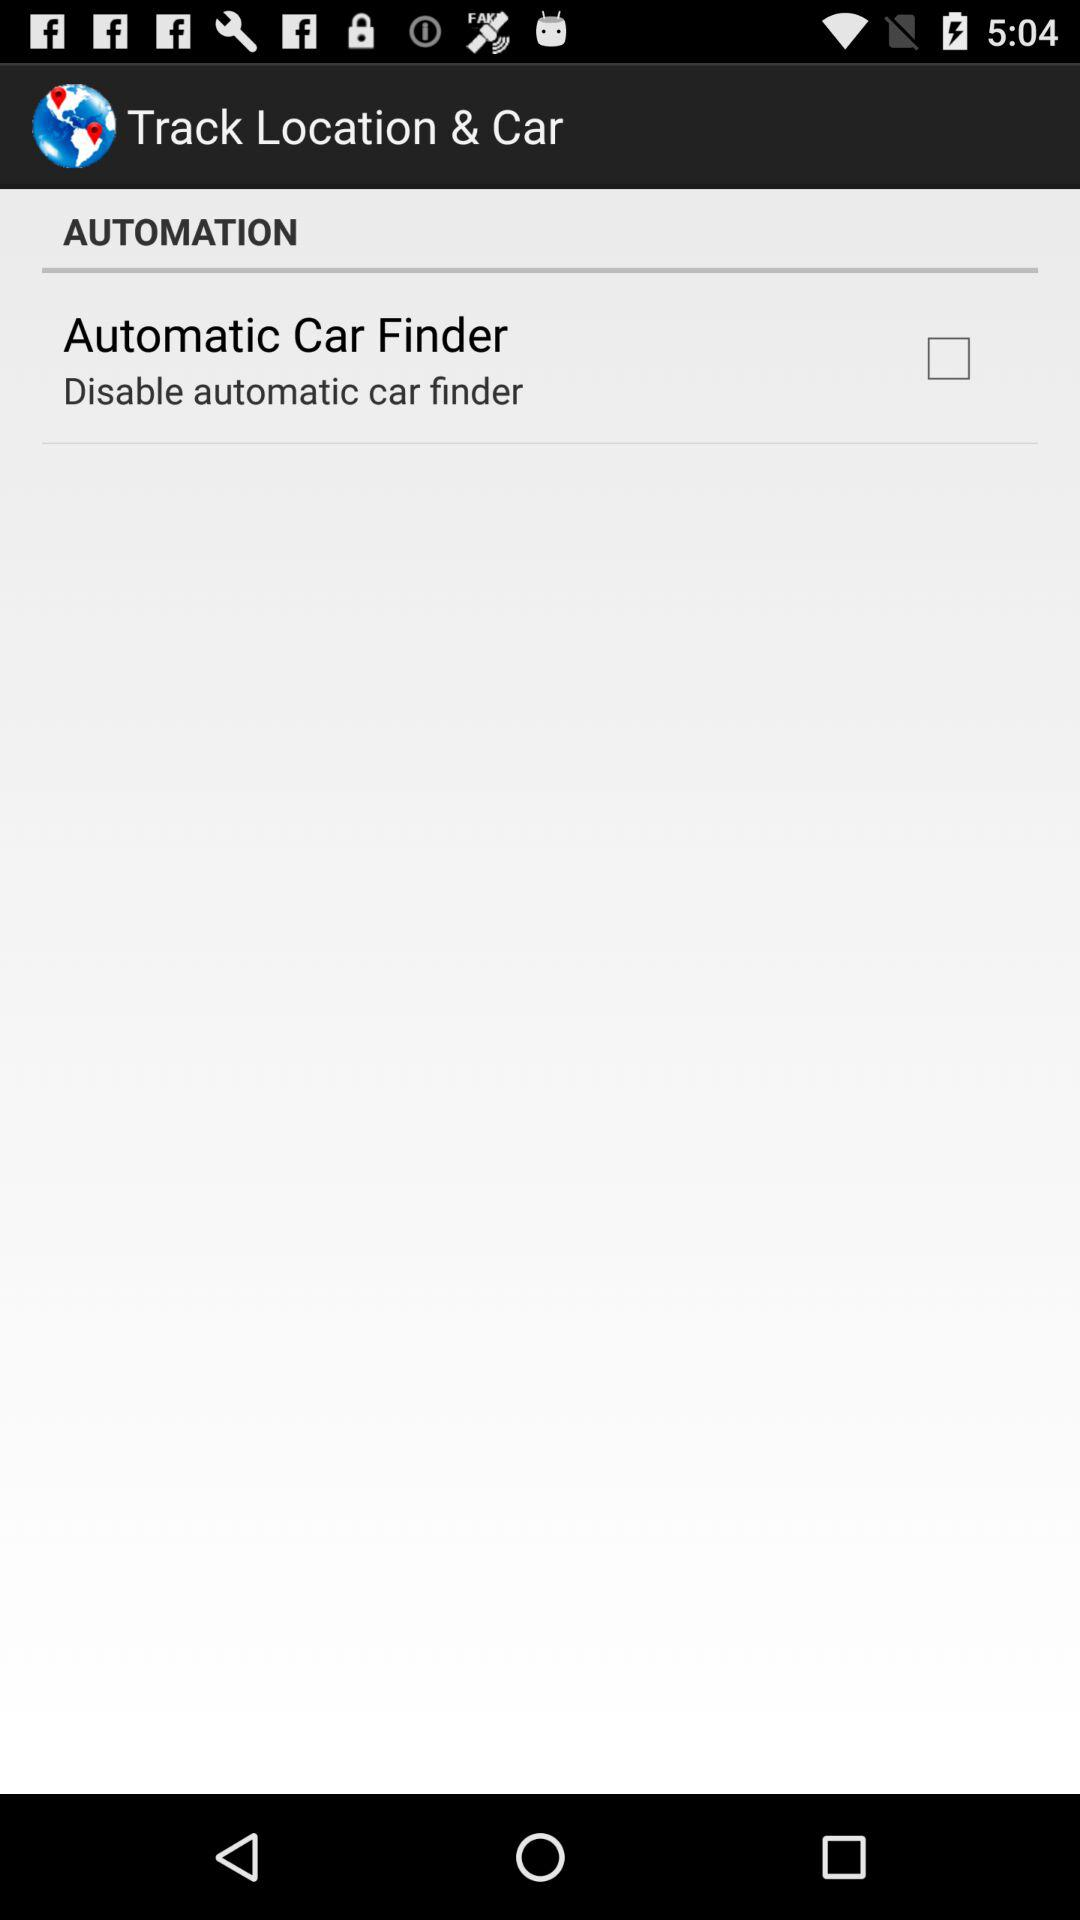What is the application name? Thee application name is "Track Location & Car". 